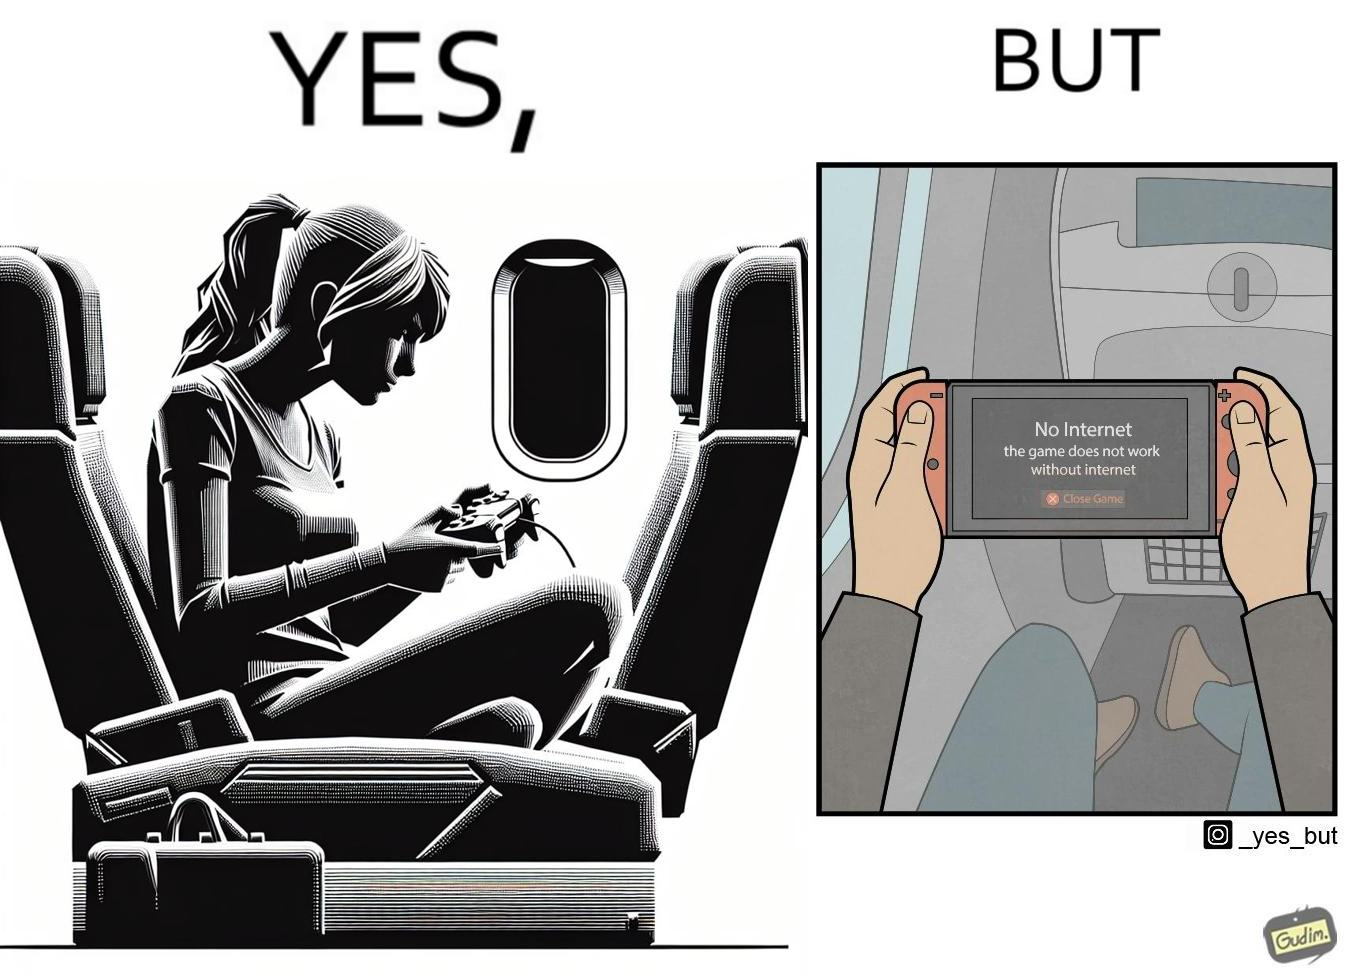Explain the humor or irony in this image. The image is ironic, as the person is holding the game console to play a game during the flight. However, the person is unable to play the game, as the game requires internet (as is the case with many modern games), and internet is unavailable in many lights. 